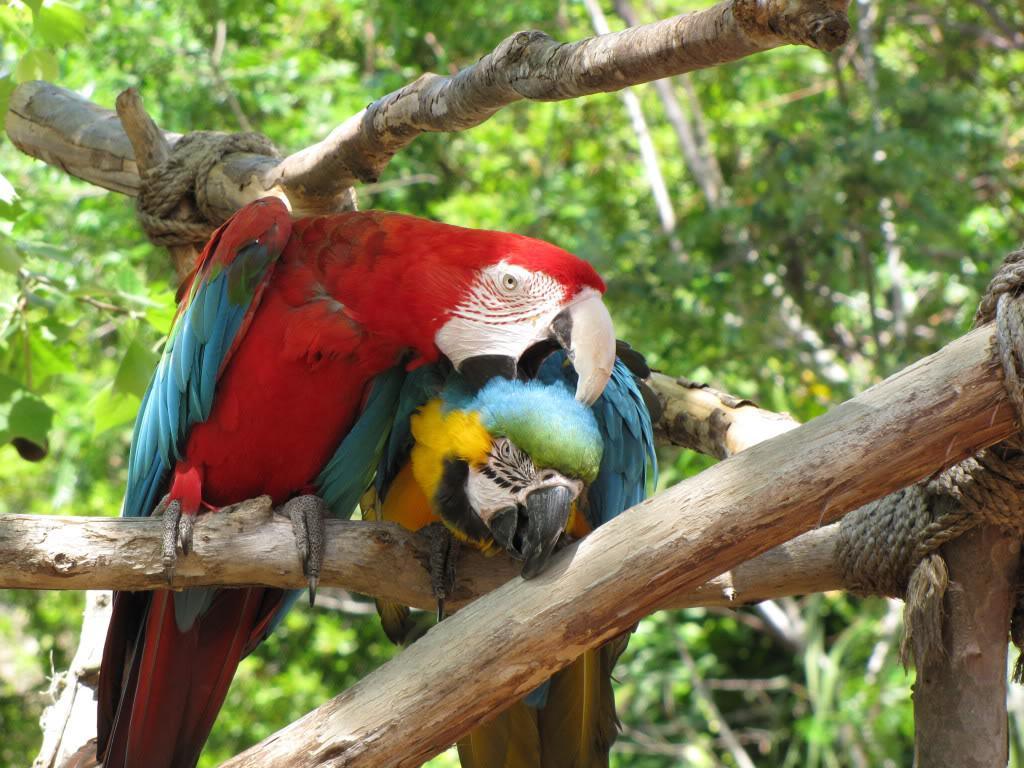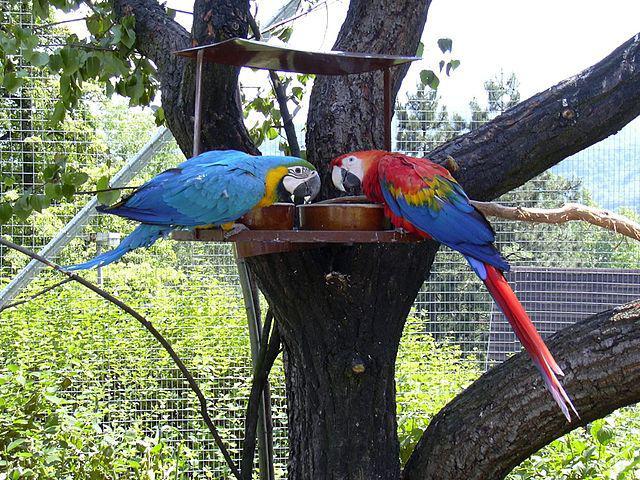The first image is the image on the left, the second image is the image on the right. For the images displayed, is the sentence "There are a large number of parrots perched on a rocky wall." factually correct? Answer yes or no. No. 